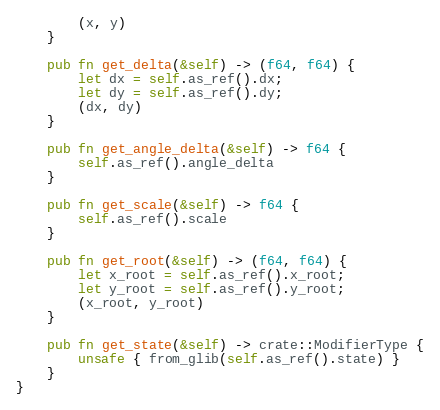Convert code to text. <code><loc_0><loc_0><loc_500><loc_500><_Rust_>        (x, y)
    }

    pub fn get_delta(&self) -> (f64, f64) {
        let dx = self.as_ref().dx;
        let dy = self.as_ref().dy;
        (dx, dy)
    }

    pub fn get_angle_delta(&self) -> f64 {
        self.as_ref().angle_delta
    }

    pub fn get_scale(&self) -> f64 {
        self.as_ref().scale
    }

    pub fn get_root(&self) -> (f64, f64) {
        let x_root = self.as_ref().x_root;
        let y_root = self.as_ref().y_root;
        (x_root, y_root)
    }

    pub fn get_state(&self) -> crate::ModifierType {
        unsafe { from_glib(self.as_ref().state) }
    }
}
</code> 